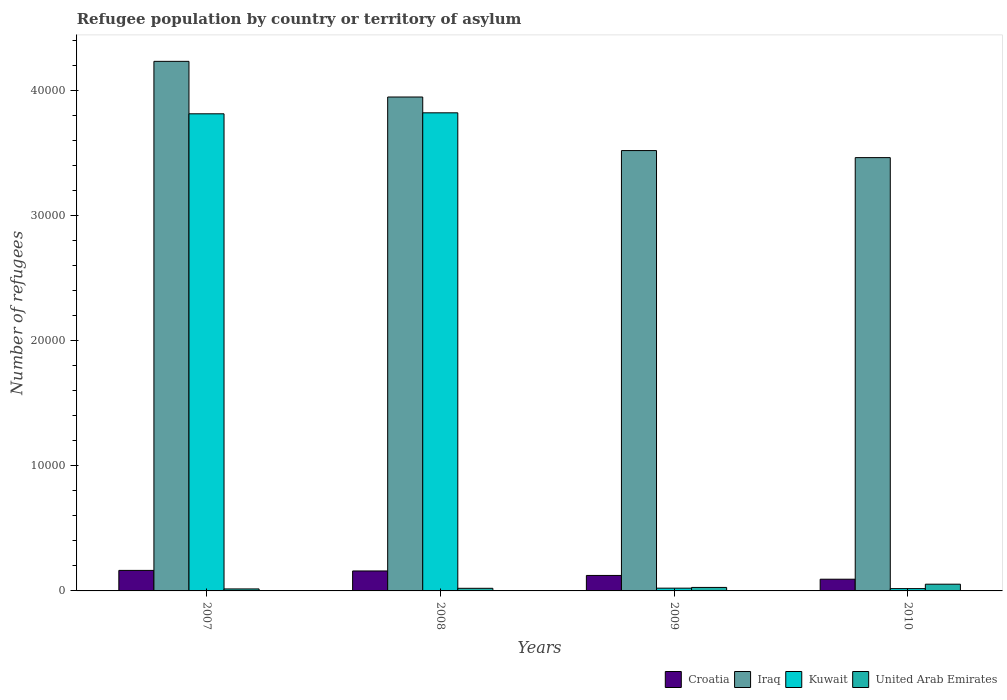How many different coloured bars are there?
Keep it short and to the point. 4. How many groups of bars are there?
Offer a very short reply. 4. Are the number of bars per tick equal to the number of legend labels?
Your response must be concise. Yes. How many bars are there on the 1st tick from the left?
Offer a terse response. 4. What is the label of the 4th group of bars from the left?
Your answer should be compact. 2010. What is the number of refugees in Iraq in 2010?
Your answer should be very brief. 3.47e+04. Across all years, what is the maximum number of refugees in United Arab Emirates?
Ensure brevity in your answer.  538. Across all years, what is the minimum number of refugees in Kuwait?
Your response must be concise. 184. In which year was the number of refugees in United Arab Emirates maximum?
Provide a short and direct response. 2010. In which year was the number of refugees in United Arab Emirates minimum?
Provide a short and direct response. 2007. What is the total number of refugees in Iraq in the graph?
Keep it short and to the point. 1.52e+05. What is the difference between the number of refugees in Iraq in 2007 and that in 2010?
Keep it short and to the point. 7699. What is the difference between the number of refugees in Iraq in 2008 and the number of refugees in Kuwait in 2009?
Offer a terse response. 3.93e+04. What is the average number of refugees in Kuwait per year?
Your response must be concise. 1.92e+04. In the year 2010, what is the difference between the number of refugees in Iraq and number of refugees in United Arab Emirates?
Offer a terse response. 3.41e+04. What is the ratio of the number of refugees in Iraq in 2008 to that in 2009?
Provide a succinct answer. 1.12. Is the difference between the number of refugees in Iraq in 2009 and 2010 greater than the difference between the number of refugees in United Arab Emirates in 2009 and 2010?
Keep it short and to the point. Yes. What is the difference between the highest and the second highest number of refugees in United Arab Emirates?
Provide a succinct answer. 259. What is the difference between the highest and the lowest number of refugees in Iraq?
Ensure brevity in your answer.  7699. In how many years, is the number of refugees in Iraq greater than the average number of refugees in Iraq taken over all years?
Ensure brevity in your answer.  2. Is the sum of the number of refugees in Iraq in 2007 and 2008 greater than the maximum number of refugees in Croatia across all years?
Offer a very short reply. Yes. Is it the case that in every year, the sum of the number of refugees in United Arab Emirates and number of refugees in Croatia is greater than the sum of number of refugees in Kuwait and number of refugees in Iraq?
Offer a terse response. Yes. What does the 1st bar from the left in 2008 represents?
Provide a succinct answer. Croatia. What does the 1st bar from the right in 2010 represents?
Make the answer very short. United Arab Emirates. Are all the bars in the graph horizontal?
Ensure brevity in your answer.  No. Does the graph contain grids?
Make the answer very short. No. Where does the legend appear in the graph?
Keep it short and to the point. Bottom right. How many legend labels are there?
Ensure brevity in your answer.  4. What is the title of the graph?
Keep it short and to the point. Refugee population by country or territory of asylum. Does "Northern Mariana Islands" appear as one of the legend labels in the graph?
Give a very brief answer. No. What is the label or title of the X-axis?
Your answer should be very brief. Years. What is the label or title of the Y-axis?
Provide a succinct answer. Number of refugees. What is the Number of refugees of Croatia in 2007?
Your answer should be very brief. 1642. What is the Number of refugees in Iraq in 2007?
Give a very brief answer. 4.24e+04. What is the Number of refugees in Kuwait in 2007?
Provide a short and direct response. 3.82e+04. What is the Number of refugees of United Arab Emirates in 2007?
Your response must be concise. 159. What is the Number of refugees of Croatia in 2008?
Provide a short and direct response. 1597. What is the Number of refugees in Iraq in 2008?
Give a very brief answer. 3.95e+04. What is the Number of refugees in Kuwait in 2008?
Keep it short and to the point. 3.82e+04. What is the Number of refugees in United Arab Emirates in 2008?
Offer a very short reply. 209. What is the Number of refugees in Croatia in 2009?
Provide a succinct answer. 1238. What is the Number of refugees of Iraq in 2009?
Provide a succinct answer. 3.52e+04. What is the Number of refugees in Kuwait in 2009?
Provide a succinct answer. 221. What is the Number of refugees in United Arab Emirates in 2009?
Your answer should be compact. 279. What is the Number of refugees in Croatia in 2010?
Your answer should be compact. 936. What is the Number of refugees in Iraq in 2010?
Keep it short and to the point. 3.47e+04. What is the Number of refugees in Kuwait in 2010?
Your answer should be compact. 184. What is the Number of refugees in United Arab Emirates in 2010?
Give a very brief answer. 538. Across all years, what is the maximum Number of refugees in Croatia?
Your answer should be compact. 1642. Across all years, what is the maximum Number of refugees of Iraq?
Your response must be concise. 4.24e+04. Across all years, what is the maximum Number of refugees in Kuwait?
Give a very brief answer. 3.82e+04. Across all years, what is the maximum Number of refugees in United Arab Emirates?
Provide a short and direct response. 538. Across all years, what is the minimum Number of refugees in Croatia?
Offer a terse response. 936. Across all years, what is the minimum Number of refugees in Iraq?
Offer a terse response. 3.47e+04. Across all years, what is the minimum Number of refugees in Kuwait?
Provide a succinct answer. 184. Across all years, what is the minimum Number of refugees in United Arab Emirates?
Your response must be concise. 159. What is the total Number of refugees in Croatia in the graph?
Provide a short and direct response. 5413. What is the total Number of refugees in Iraq in the graph?
Provide a succinct answer. 1.52e+05. What is the total Number of refugees in Kuwait in the graph?
Your answer should be very brief. 7.68e+04. What is the total Number of refugees in United Arab Emirates in the graph?
Offer a terse response. 1185. What is the difference between the Number of refugees of Iraq in 2007 and that in 2008?
Give a very brief answer. 2851. What is the difference between the Number of refugees in Kuwait in 2007 and that in 2008?
Give a very brief answer. -79. What is the difference between the Number of refugees in Croatia in 2007 and that in 2009?
Offer a very short reply. 404. What is the difference between the Number of refugees of Iraq in 2007 and that in 2009?
Ensure brevity in your answer.  7136. What is the difference between the Number of refugees in Kuwait in 2007 and that in 2009?
Your answer should be compact. 3.79e+04. What is the difference between the Number of refugees of United Arab Emirates in 2007 and that in 2009?
Provide a short and direct response. -120. What is the difference between the Number of refugees in Croatia in 2007 and that in 2010?
Offer a very short reply. 706. What is the difference between the Number of refugees in Iraq in 2007 and that in 2010?
Ensure brevity in your answer.  7699. What is the difference between the Number of refugees of Kuwait in 2007 and that in 2010?
Offer a terse response. 3.80e+04. What is the difference between the Number of refugees of United Arab Emirates in 2007 and that in 2010?
Provide a short and direct response. -379. What is the difference between the Number of refugees of Croatia in 2008 and that in 2009?
Your response must be concise. 359. What is the difference between the Number of refugees of Iraq in 2008 and that in 2009?
Your response must be concise. 4285. What is the difference between the Number of refugees of Kuwait in 2008 and that in 2009?
Your response must be concise. 3.80e+04. What is the difference between the Number of refugees of United Arab Emirates in 2008 and that in 2009?
Keep it short and to the point. -70. What is the difference between the Number of refugees of Croatia in 2008 and that in 2010?
Keep it short and to the point. 661. What is the difference between the Number of refugees in Iraq in 2008 and that in 2010?
Provide a short and direct response. 4848. What is the difference between the Number of refugees of Kuwait in 2008 and that in 2010?
Make the answer very short. 3.81e+04. What is the difference between the Number of refugees of United Arab Emirates in 2008 and that in 2010?
Your response must be concise. -329. What is the difference between the Number of refugees in Croatia in 2009 and that in 2010?
Offer a very short reply. 302. What is the difference between the Number of refugees in Iraq in 2009 and that in 2010?
Your answer should be very brief. 563. What is the difference between the Number of refugees of United Arab Emirates in 2009 and that in 2010?
Offer a terse response. -259. What is the difference between the Number of refugees in Croatia in 2007 and the Number of refugees in Iraq in 2008?
Offer a terse response. -3.79e+04. What is the difference between the Number of refugees in Croatia in 2007 and the Number of refugees in Kuwait in 2008?
Give a very brief answer. -3.66e+04. What is the difference between the Number of refugees of Croatia in 2007 and the Number of refugees of United Arab Emirates in 2008?
Your answer should be very brief. 1433. What is the difference between the Number of refugees of Iraq in 2007 and the Number of refugees of Kuwait in 2008?
Your response must be concise. 4116. What is the difference between the Number of refugees in Iraq in 2007 and the Number of refugees in United Arab Emirates in 2008?
Offer a terse response. 4.21e+04. What is the difference between the Number of refugees in Kuwait in 2007 and the Number of refugees in United Arab Emirates in 2008?
Make the answer very short. 3.80e+04. What is the difference between the Number of refugees in Croatia in 2007 and the Number of refugees in Iraq in 2009?
Ensure brevity in your answer.  -3.36e+04. What is the difference between the Number of refugees in Croatia in 2007 and the Number of refugees in Kuwait in 2009?
Your answer should be very brief. 1421. What is the difference between the Number of refugees in Croatia in 2007 and the Number of refugees in United Arab Emirates in 2009?
Keep it short and to the point. 1363. What is the difference between the Number of refugees in Iraq in 2007 and the Number of refugees in Kuwait in 2009?
Make the answer very short. 4.21e+04. What is the difference between the Number of refugees of Iraq in 2007 and the Number of refugees of United Arab Emirates in 2009?
Make the answer very short. 4.21e+04. What is the difference between the Number of refugees of Kuwait in 2007 and the Number of refugees of United Arab Emirates in 2009?
Your answer should be very brief. 3.79e+04. What is the difference between the Number of refugees of Croatia in 2007 and the Number of refugees of Iraq in 2010?
Provide a succinct answer. -3.30e+04. What is the difference between the Number of refugees of Croatia in 2007 and the Number of refugees of Kuwait in 2010?
Your answer should be compact. 1458. What is the difference between the Number of refugees in Croatia in 2007 and the Number of refugees in United Arab Emirates in 2010?
Your answer should be very brief. 1104. What is the difference between the Number of refugees of Iraq in 2007 and the Number of refugees of Kuwait in 2010?
Give a very brief answer. 4.22e+04. What is the difference between the Number of refugees in Iraq in 2007 and the Number of refugees in United Arab Emirates in 2010?
Ensure brevity in your answer.  4.18e+04. What is the difference between the Number of refugees in Kuwait in 2007 and the Number of refugees in United Arab Emirates in 2010?
Provide a succinct answer. 3.76e+04. What is the difference between the Number of refugees in Croatia in 2008 and the Number of refugees in Iraq in 2009?
Your answer should be very brief. -3.36e+04. What is the difference between the Number of refugees in Croatia in 2008 and the Number of refugees in Kuwait in 2009?
Your answer should be very brief. 1376. What is the difference between the Number of refugees in Croatia in 2008 and the Number of refugees in United Arab Emirates in 2009?
Ensure brevity in your answer.  1318. What is the difference between the Number of refugees of Iraq in 2008 and the Number of refugees of Kuwait in 2009?
Your answer should be very brief. 3.93e+04. What is the difference between the Number of refugees of Iraq in 2008 and the Number of refugees of United Arab Emirates in 2009?
Keep it short and to the point. 3.92e+04. What is the difference between the Number of refugees of Kuwait in 2008 and the Number of refugees of United Arab Emirates in 2009?
Your answer should be very brief. 3.80e+04. What is the difference between the Number of refugees in Croatia in 2008 and the Number of refugees in Iraq in 2010?
Offer a very short reply. -3.31e+04. What is the difference between the Number of refugees of Croatia in 2008 and the Number of refugees of Kuwait in 2010?
Provide a succinct answer. 1413. What is the difference between the Number of refugees in Croatia in 2008 and the Number of refugees in United Arab Emirates in 2010?
Make the answer very short. 1059. What is the difference between the Number of refugees in Iraq in 2008 and the Number of refugees in Kuwait in 2010?
Give a very brief answer. 3.93e+04. What is the difference between the Number of refugees in Iraq in 2008 and the Number of refugees in United Arab Emirates in 2010?
Ensure brevity in your answer.  3.90e+04. What is the difference between the Number of refugees of Kuwait in 2008 and the Number of refugees of United Arab Emirates in 2010?
Your answer should be compact. 3.77e+04. What is the difference between the Number of refugees in Croatia in 2009 and the Number of refugees in Iraq in 2010?
Your answer should be very brief. -3.34e+04. What is the difference between the Number of refugees in Croatia in 2009 and the Number of refugees in Kuwait in 2010?
Keep it short and to the point. 1054. What is the difference between the Number of refugees in Croatia in 2009 and the Number of refugees in United Arab Emirates in 2010?
Make the answer very short. 700. What is the difference between the Number of refugees of Iraq in 2009 and the Number of refugees of Kuwait in 2010?
Make the answer very short. 3.50e+04. What is the difference between the Number of refugees in Iraq in 2009 and the Number of refugees in United Arab Emirates in 2010?
Ensure brevity in your answer.  3.47e+04. What is the difference between the Number of refugees of Kuwait in 2009 and the Number of refugees of United Arab Emirates in 2010?
Ensure brevity in your answer.  -317. What is the average Number of refugees in Croatia per year?
Provide a short and direct response. 1353.25. What is the average Number of refugees in Iraq per year?
Make the answer very short. 3.79e+04. What is the average Number of refugees of Kuwait per year?
Your answer should be compact. 1.92e+04. What is the average Number of refugees in United Arab Emirates per year?
Your answer should be very brief. 296.25. In the year 2007, what is the difference between the Number of refugees of Croatia and Number of refugees of Iraq?
Give a very brief answer. -4.07e+04. In the year 2007, what is the difference between the Number of refugees of Croatia and Number of refugees of Kuwait?
Your answer should be very brief. -3.65e+04. In the year 2007, what is the difference between the Number of refugees of Croatia and Number of refugees of United Arab Emirates?
Give a very brief answer. 1483. In the year 2007, what is the difference between the Number of refugees of Iraq and Number of refugees of Kuwait?
Ensure brevity in your answer.  4195. In the year 2007, what is the difference between the Number of refugees in Iraq and Number of refugees in United Arab Emirates?
Your answer should be compact. 4.22e+04. In the year 2007, what is the difference between the Number of refugees of Kuwait and Number of refugees of United Arab Emirates?
Give a very brief answer. 3.80e+04. In the year 2008, what is the difference between the Number of refugees of Croatia and Number of refugees of Iraq?
Your answer should be compact. -3.79e+04. In the year 2008, what is the difference between the Number of refugees of Croatia and Number of refugees of Kuwait?
Keep it short and to the point. -3.66e+04. In the year 2008, what is the difference between the Number of refugees of Croatia and Number of refugees of United Arab Emirates?
Offer a very short reply. 1388. In the year 2008, what is the difference between the Number of refugees in Iraq and Number of refugees in Kuwait?
Give a very brief answer. 1265. In the year 2008, what is the difference between the Number of refugees in Iraq and Number of refugees in United Arab Emirates?
Offer a very short reply. 3.93e+04. In the year 2008, what is the difference between the Number of refugees of Kuwait and Number of refugees of United Arab Emirates?
Keep it short and to the point. 3.80e+04. In the year 2009, what is the difference between the Number of refugees in Croatia and Number of refugees in Iraq?
Give a very brief answer. -3.40e+04. In the year 2009, what is the difference between the Number of refugees in Croatia and Number of refugees in Kuwait?
Offer a very short reply. 1017. In the year 2009, what is the difference between the Number of refugees of Croatia and Number of refugees of United Arab Emirates?
Provide a short and direct response. 959. In the year 2009, what is the difference between the Number of refugees in Iraq and Number of refugees in Kuwait?
Make the answer very short. 3.50e+04. In the year 2009, what is the difference between the Number of refugees of Iraq and Number of refugees of United Arab Emirates?
Offer a terse response. 3.49e+04. In the year 2009, what is the difference between the Number of refugees of Kuwait and Number of refugees of United Arab Emirates?
Offer a very short reply. -58. In the year 2010, what is the difference between the Number of refugees of Croatia and Number of refugees of Iraq?
Give a very brief answer. -3.37e+04. In the year 2010, what is the difference between the Number of refugees in Croatia and Number of refugees in Kuwait?
Ensure brevity in your answer.  752. In the year 2010, what is the difference between the Number of refugees of Croatia and Number of refugees of United Arab Emirates?
Give a very brief answer. 398. In the year 2010, what is the difference between the Number of refugees of Iraq and Number of refugees of Kuwait?
Provide a short and direct response. 3.45e+04. In the year 2010, what is the difference between the Number of refugees of Iraq and Number of refugees of United Arab Emirates?
Your answer should be compact. 3.41e+04. In the year 2010, what is the difference between the Number of refugees of Kuwait and Number of refugees of United Arab Emirates?
Offer a very short reply. -354. What is the ratio of the Number of refugees of Croatia in 2007 to that in 2008?
Ensure brevity in your answer.  1.03. What is the ratio of the Number of refugees in Iraq in 2007 to that in 2008?
Provide a short and direct response. 1.07. What is the ratio of the Number of refugees of Kuwait in 2007 to that in 2008?
Make the answer very short. 1. What is the ratio of the Number of refugees of United Arab Emirates in 2007 to that in 2008?
Offer a very short reply. 0.76. What is the ratio of the Number of refugees of Croatia in 2007 to that in 2009?
Your answer should be very brief. 1.33. What is the ratio of the Number of refugees in Iraq in 2007 to that in 2009?
Your answer should be very brief. 1.2. What is the ratio of the Number of refugees of Kuwait in 2007 to that in 2009?
Ensure brevity in your answer.  172.67. What is the ratio of the Number of refugees in United Arab Emirates in 2007 to that in 2009?
Ensure brevity in your answer.  0.57. What is the ratio of the Number of refugees of Croatia in 2007 to that in 2010?
Keep it short and to the point. 1.75. What is the ratio of the Number of refugees in Iraq in 2007 to that in 2010?
Your answer should be compact. 1.22. What is the ratio of the Number of refugees in Kuwait in 2007 to that in 2010?
Give a very brief answer. 207.39. What is the ratio of the Number of refugees of United Arab Emirates in 2007 to that in 2010?
Give a very brief answer. 0.3. What is the ratio of the Number of refugees of Croatia in 2008 to that in 2009?
Your response must be concise. 1.29. What is the ratio of the Number of refugees in Iraq in 2008 to that in 2009?
Your answer should be compact. 1.12. What is the ratio of the Number of refugees in Kuwait in 2008 to that in 2009?
Give a very brief answer. 173.02. What is the ratio of the Number of refugees of United Arab Emirates in 2008 to that in 2009?
Keep it short and to the point. 0.75. What is the ratio of the Number of refugees of Croatia in 2008 to that in 2010?
Keep it short and to the point. 1.71. What is the ratio of the Number of refugees in Iraq in 2008 to that in 2010?
Provide a succinct answer. 1.14. What is the ratio of the Number of refugees in Kuwait in 2008 to that in 2010?
Give a very brief answer. 207.82. What is the ratio of the Number of refugees in United Arab Emirates in 2008 to that in 2010?
Offer a terse response. 0.39. What is the ratio of the Number of refugees of Croatia in 2009 to that in 2010?
Offer a terse response. 1.32. What is the ratio of the Number of refugees in Iraq in 2009 to that in 2010?
Offer a very short reply. 1.02. What is the ratio of the Number of refugees of Kuwait in 2009 to that in 2010?
Your answer should be very brief. 1.2. What is the ratio of the Number of refugees in United Arab Emirates in 2009 to that in 2010?
Give a very brief answer. 0.52. What is the difference between the highest and the second highest Number of refugees of Croatia?
Ensure brevity in your answer.  45. What is the difference between the highest and the second highest Number of refugees of Iraq?
Your response must be concise. 2851. What is the difference between the highest and the second highest Number of refugees of Kuwait?
Your answer should be very brief. 79. What is the difference between the highest and the second highest Number of refugees of United Arab Emirates?
Offer a very short reply. 259. What is the difference between the highest and the lowest Number of refugees of Croatia?
Offer a very short reply. 706. What is the difference between the highest and the lowest Number of refugees in Iraq?
Provide a succinct answer. 7699. What is the difference between the highest and the lowest Number of refugees in Kuwait?
Make the answer very short. 3.81e+04. What is the difference between the highest and the lowest Number of refugees in United Arab Emirates?
Offer a very short reply. 379. 